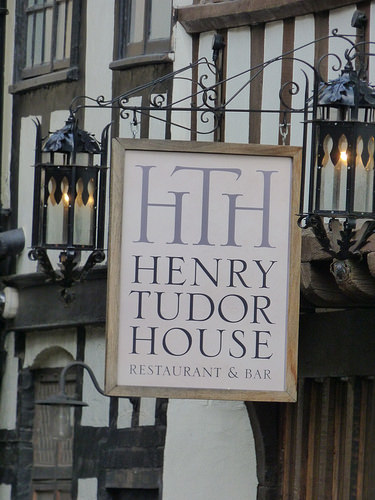<image>
Is there a sign to the right of the building? Yes. From this viewpoint, the sign is positioned to the right side relative to the building. 